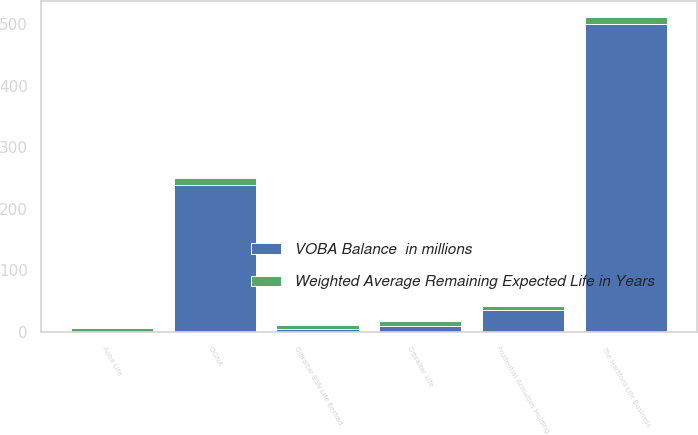Convert chart to OTSL. <chart><loc_0><loc_0><loc_500><loc_500><stacked_bar_chart><ecel><fcel>CIGNA<fcel>Prudential Annuities Holding<fcel>Gibraltar Life<fcel>Aoba Life<fcel>The Hartford Life Business<fcel>Gibraltar BSN Life Berhad<nl><fcel>VOBA Balance  in millions<fcel>238<fcel>36<fcel>9<fcel>0<fcel>500<fcel>5<nl><fcel>Weighted Average Remaining Expected Life in Years<fcel>12<fcel>6<fcel>9<fcel>7<fcel>11<fcel>7<nl></chart> 